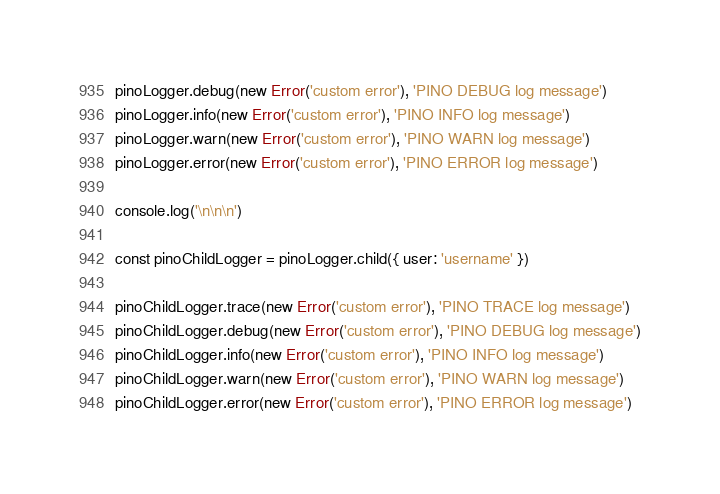Convert code to text. <code><loc_0><loc_0><loc_500><loc_500><_JavaScript_>pinoLogger.debug(new Error('custom error'), 'PINO DEBUG log message')
pinoLogger.info(new Error('custom error'), 'PINO INFO log message')
pinoLogger.warn(new Error('custom error'), 'PINO WARN log message')
pinoLogger.error(new Error('custom error'), 'PINO ERROR log message')

console.log('\n\n\n')

const pinoChildLogger = pinoLogger.child({ user: 'username' })

pinoChildLogger.trace(new Error('custom error'), 'PINO TRACE log message')
pinoChildLogger.debug(new Error('custom error'), 'PINO DEBUG log message')
pinoChildLogger.info(new Error('custom error'), 'PINO INFO log message')
pinoChildLogger.warn(new Error('custom error'), 'PINO WARN log message')
pinoChildLogger.error(new Error('custom error'), 'PINO ERROR log message')
</code> 